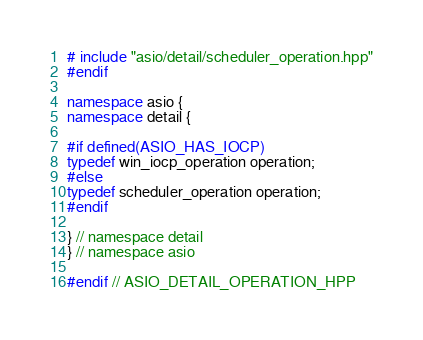<code> <loc_0><loc_0><loc_500><loc_500><_C++_># include "asio/detail/scheduler_operation.hpp"
#endif

namespace asio {
namespace detail {

#if defined(ASIO_HAS_IOCP)
typedef win_iocp_operation operation;
#else
typedef scheduler_operation operation;
#endif

} // namespace detail
} // namespace asio

#endif // ASIO_DETAIL_OPERATION_HPP
</code> 